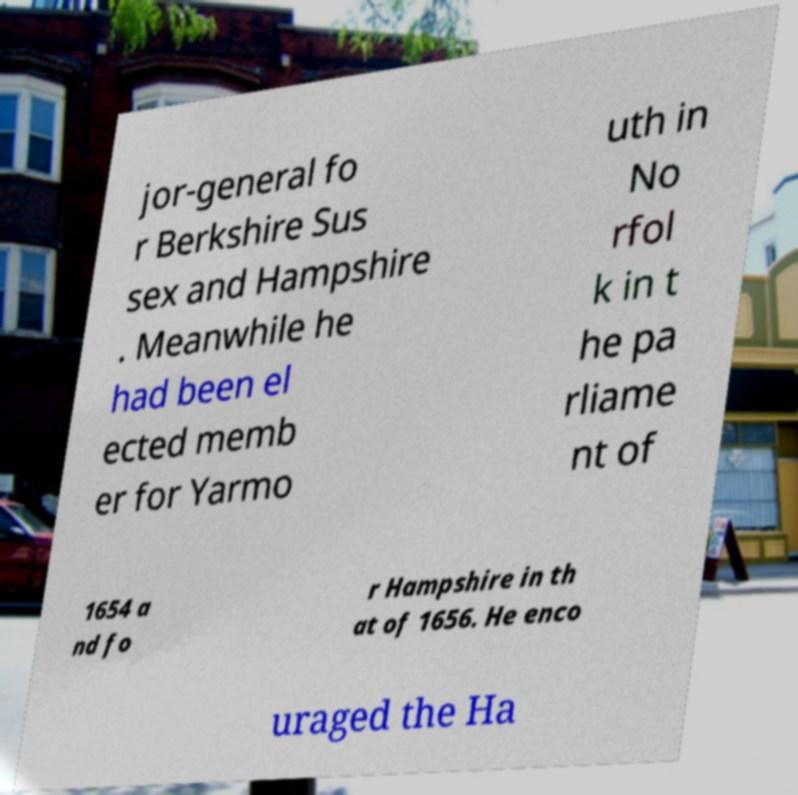Can you read and provide the text displayed in the image?This photo seems to have some interesting text. Can you extract and type it out for me? jor-general fo r Berkshire Sus sex and Hampshire . Meanwhile he had been el ected memb er for Yarmo uth in No rfol k in t he pa rliame nt of 1654 a nd fo r Hampshire in th at of 1656. He enco uraged the Ha 